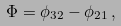<formula> <loc_0><loc_0><loc_500><loc_500>\Phi = \phi _ { 3 2 } - \phi _ { 2 1 } \, ,</formula> 